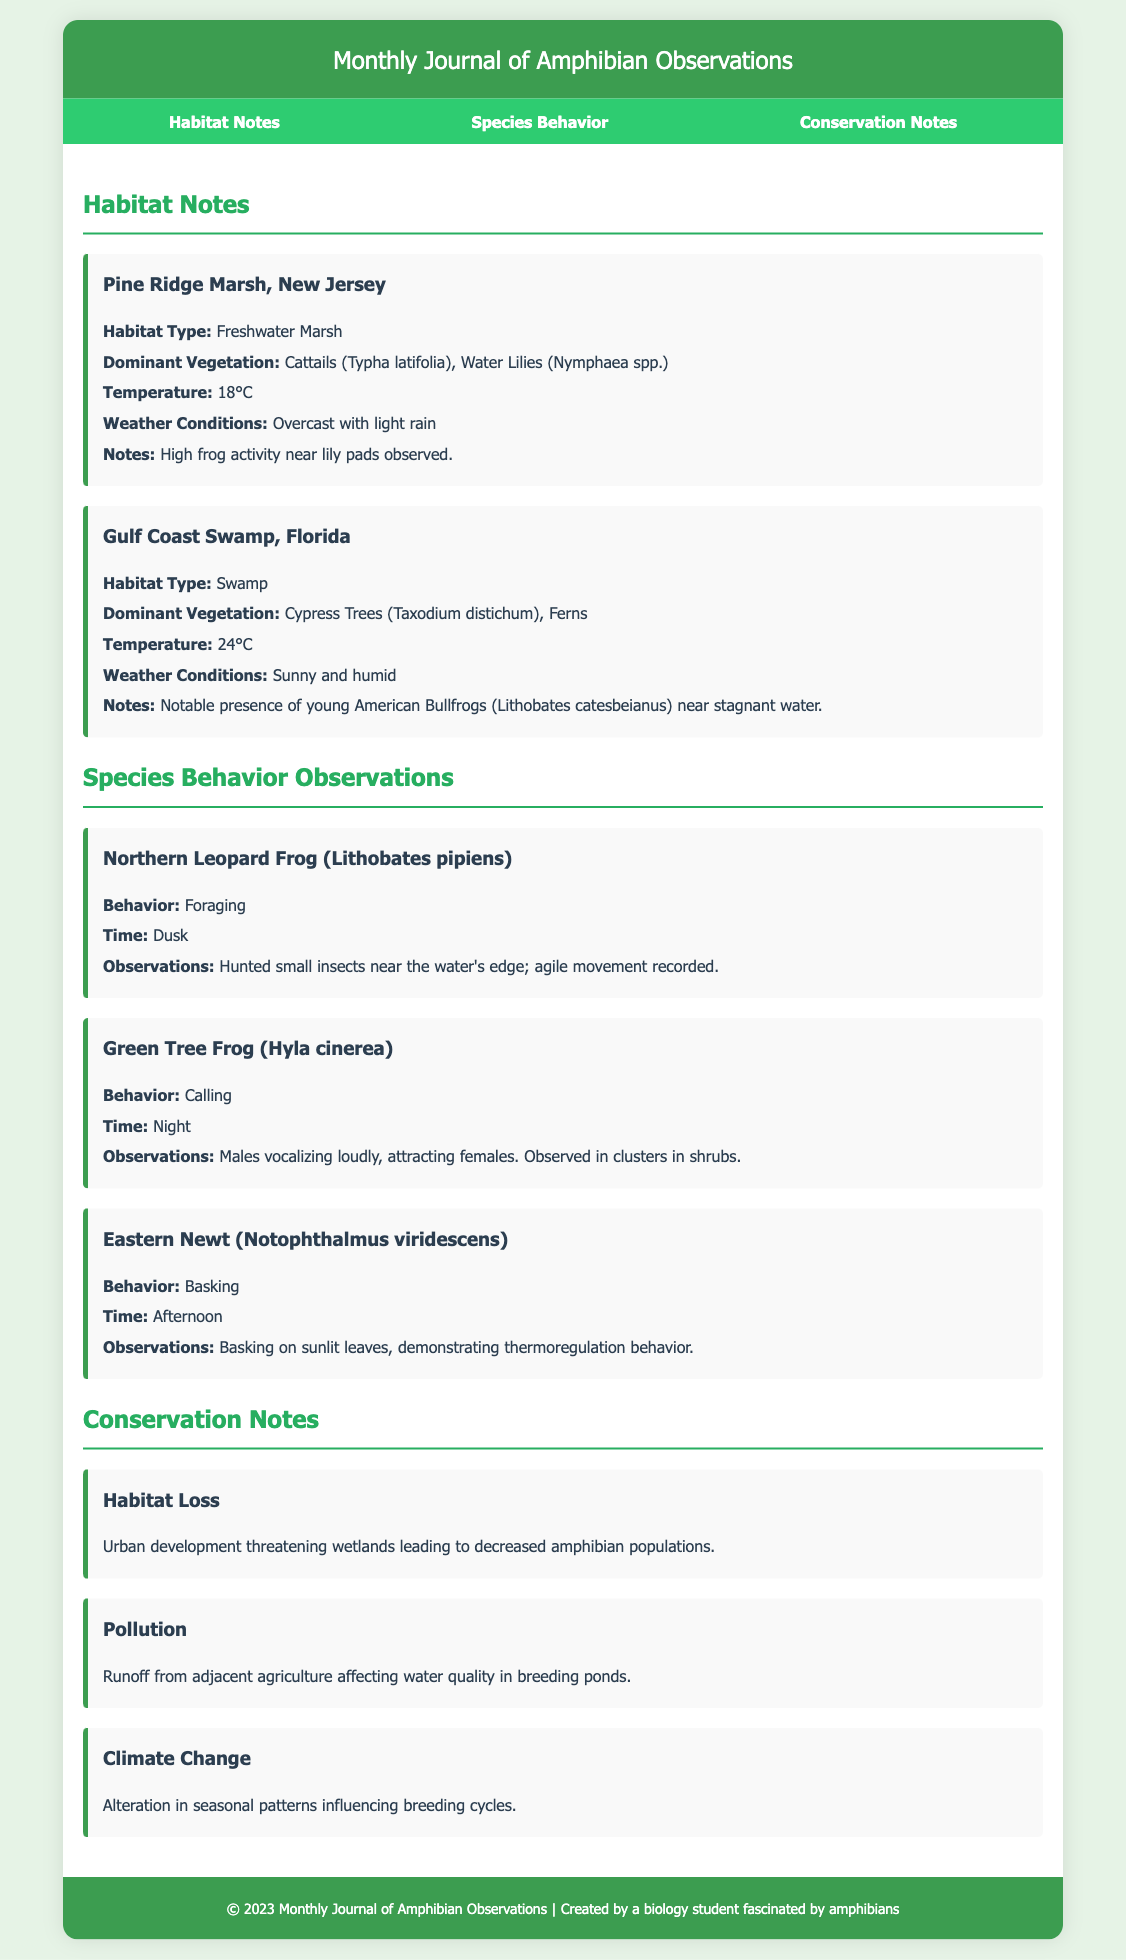What is the habitat type of Pine Ridge Marsh? The habitat type of Pine Ridge Marsh is stated explicitly in the document under habitat notes.
Answer: Freshwater Marsh What is the dominant vegetation in Gulf Coast Swamp? The document lists the dominant vegetation in Gulf Coast Swamp, which includes cypress trees and ferns.
Answer: Cypress Trees, Ferns What temperature was recorded at Pine Ridge Marsh? The document specifies the temperature in the habitat notes section for Pine Ridge Marsh.
Answer: 18°C What specific behavior was observed for the Northern Leopard Frog? The behavior observed is detailed in the species behavior section under the relevant species.
Answer: Foraging At what time did the Green Tree Frog exhibit calling behavior? The time for the calling behavior of the Green Tree Frog is provided in the document for that species.
Answer: Night What environmental issue is mentioned related to habitat loss? The document raises concerns about an environmental issue affecting amphibians, particularly connected to urban development.
Answer: Urban development How does climate change affect amphibians according to the document? The document outlines the effects of climate change specifically regarding breeding cycles.
Answer: Influencing breeding cycles What notable amphibian is present in Gulf Coast Swamp? The document mentions a specific amphibian's presence in the Gulf Coast Swamp observation.
Answer: American Bullfrogs What is the overall theme of the Monthly Journal of Amphibian Observations? The journal focuses on observational data regarding amphibians' species behavior and habitat, captured within its sections.
Answer: Amphibian observations 